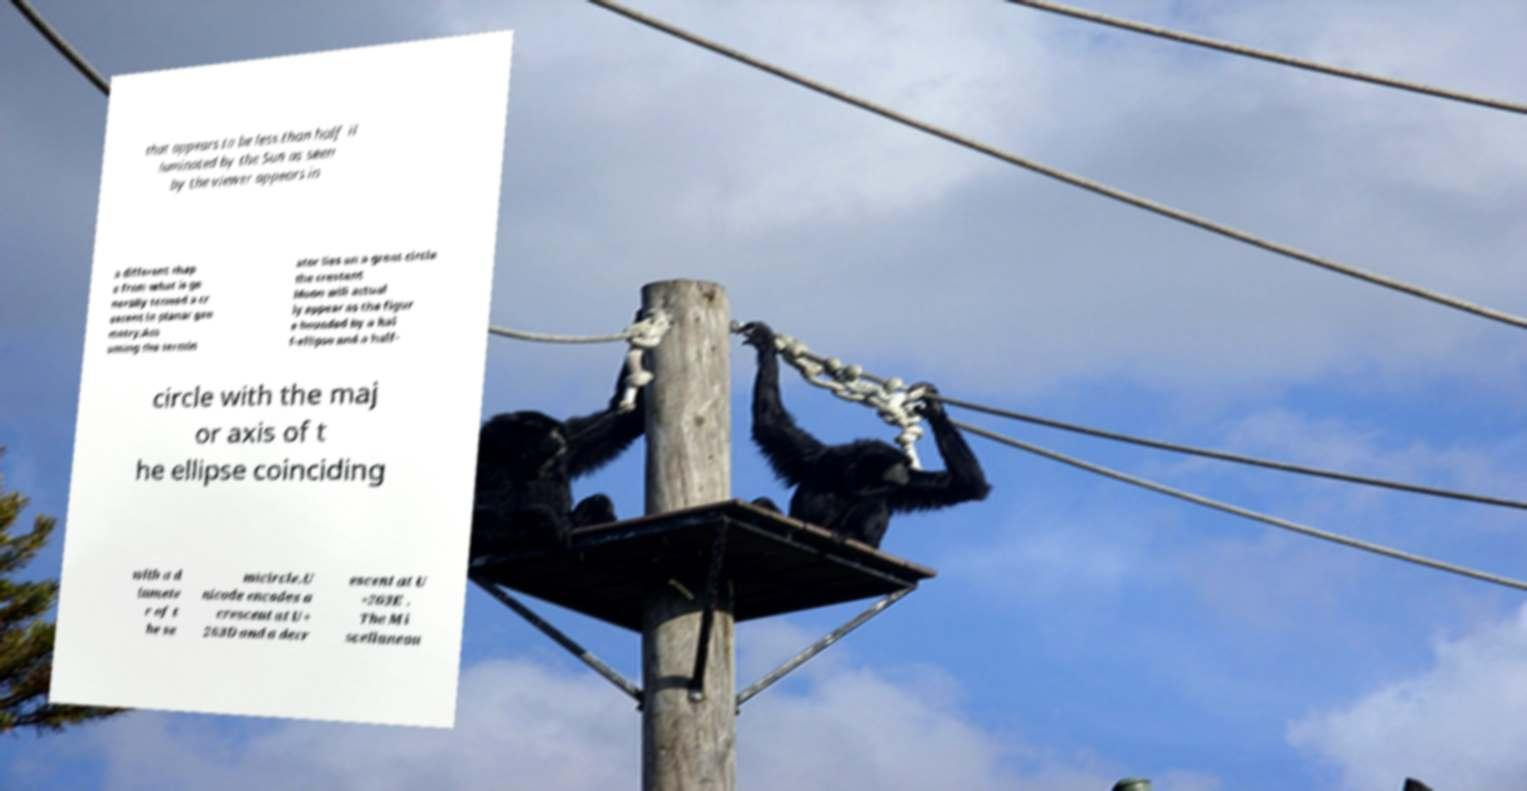Can you accurately transcribe the text from the provided image for me? that appears to be less than half il luminated by the Sun as seen by the viewer appears in a different shap e from what is ge nerally termed a cr escent in planar geo metry:Ass uming the termin ator lies on a great circle the crescent Moon will actual ly appear as the figur e bounded by a hal f-ellipse and a half- circle with the maj or axis of t he ellipse coinciding with a d iamete r of t he se micircle.U nicode encodes a crescent at U+ 263D and a decr escent at U +263E . The Mi scellaneou 